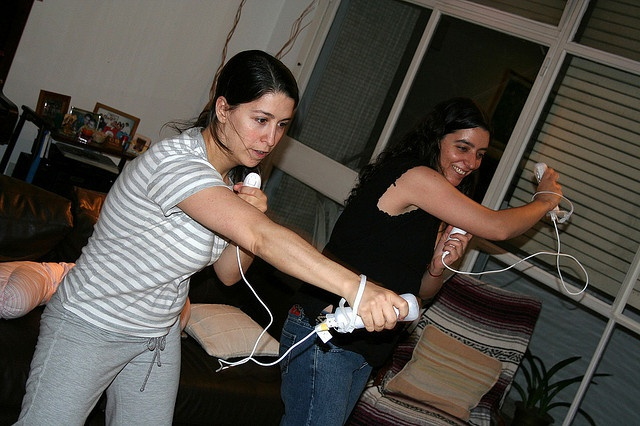Describe the objects in this image and their specific colors. I can see people in black, darkgray, lightgray, and tan tones, people in black, brown, and navy tones, couch in black, maroon, gray, and white tones, chair in black, gray, and brown tones, and potted plant in black, gray, and purple tones in this image. 